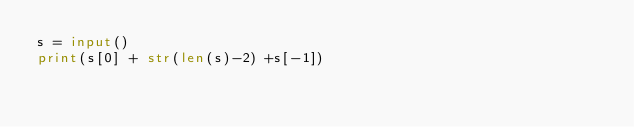<code> <loc_0><loc_0><loc_500><loc_500><_Python_>s = input()
print(s[0] + str(len(s)-2) +s[-1])</code> 